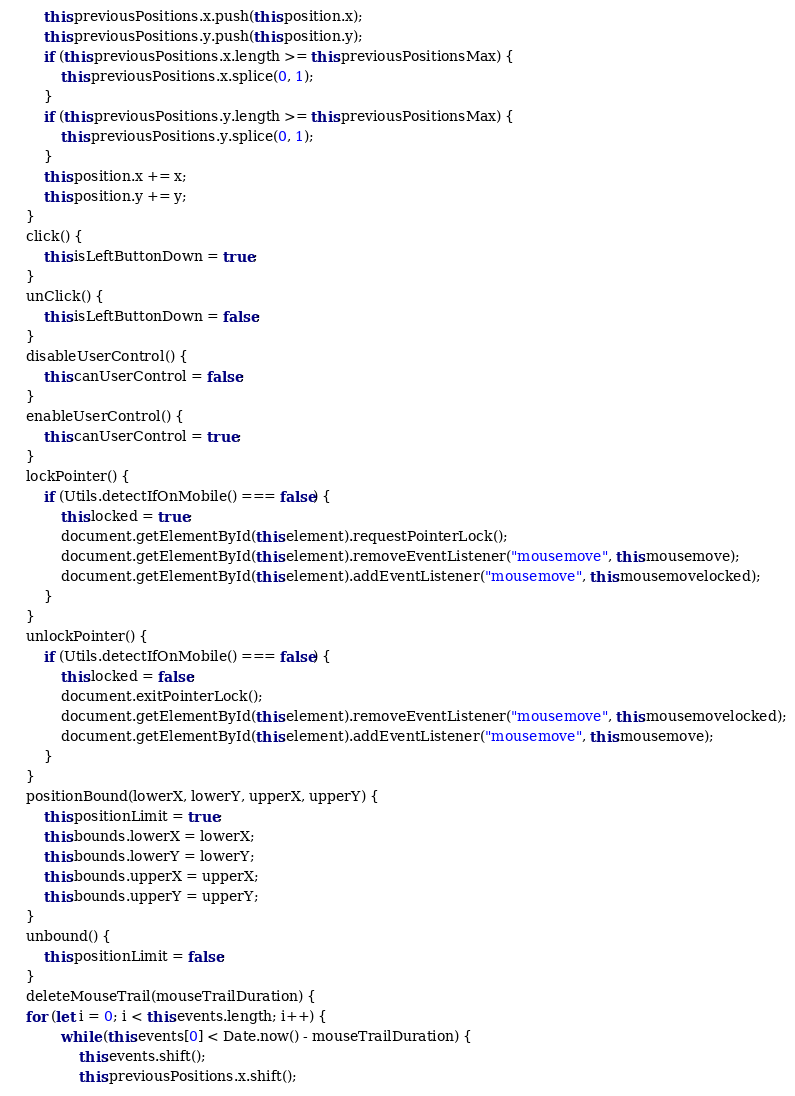Convert code to text. <code><loc_0><loc_0><loc_500><loc_500><_JavaScript_>		this.previousPositions.x.push(this.position.x);
		this.previousPositions.y.push(this.position.y);
		if (this.previousPositions.x.length >= this.previousPositionsMax) {
			this.previousPositions.x.splice(0, 1);
		}
		if (this.previousPositions.y.length >= this.previousPositionsMax) {
			this.previousPositions.y.splice(0, 1);
		}
		this.position.x += x;
		this.position.y += y;
	}
	click() {
		this.isLeftButtonDown = true;
	}
	unClick() {
		this.isLeftButtonDown = false;
	}
	disableUserControl() {
		this.canUserControl = false;
	}
	enableUserControl() {
		this.canUserControl = true;
	}
	lockPointer() {
		if (Utils.detectIfOnMobile() === false) {
			this.locked = true;
			document.getElementById(this.element).requestPointerLock();
			document.getElementById(this.element).removeEventListener("mousemove", this.mousemove);
			document.getElementById(this.element).addEventListener("mousemove", this.mousemovelocked);
		}
	}
	unlockPointer() {
		if (Utils.detectIfOnMobile() === false) {
			this.locked = false;
			document.exitPointerLock();
			document.getElementById(this.element).removeEventListener("mousemove", this.mousemovelocked);
			document.getElementById(this.element).addEventListener("mousemove", this.mousemove);
		}
	}
	positionBound(lowerX, lowerY, upperX, upperY) {
		this.positionLimit = true;
		this.bounds.lowerX = lowerX;
		this.bounds.lowerY = lowerY;
		this.bounds.upperX = upperX;
		this.bounds.upperY = upperY;
	}
	unbound() {
		this.positionLimit = false;
	}
	deleteMouseTrail(mouseTrailDuration) {
	for (let i = 0; i < this.events.length; i++) {
			while (this.events[0] < Date.now() - mouseTrailDuration) {
				this.events.shift();
				this.previousPositions.x.shift();</code> 